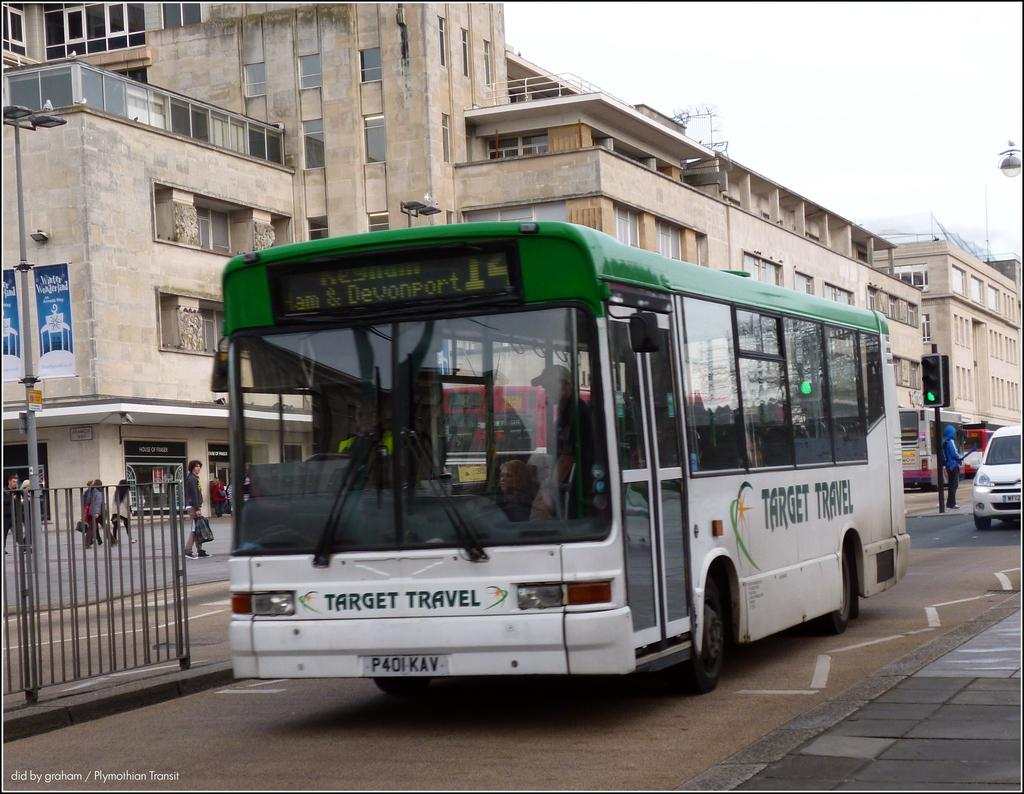<image>
Give a short and clear explanation of the subsequent image. target travel 14 bus line ham and davenport line 